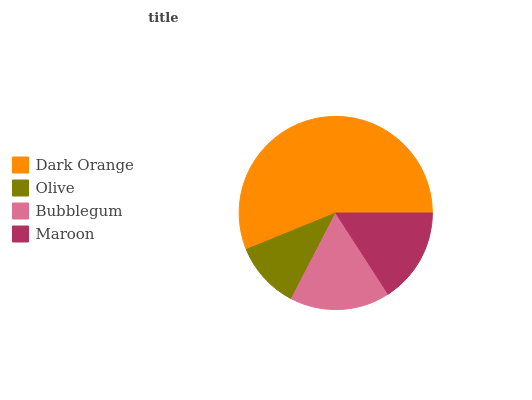Is Olive the minimum?
Answer yes or no. Yes. Is Dark Orange the maximum?
Answer yes or no. Yes. Is Bubblegum the minimum?
Answer yes or no. No. Is Bubblegum the maximum?
Answer yes or no. No. Is Bubblegum greater than Olive?
Answer yes or no. Yes. Is Olive less than Bubblegum?
Answer yes or no. Yes. Is Olive greater than Bubblegum?
Answer yes or no. No. Is Bubblegum less than Olive?
Answer yes or no. No. Is Bubblegum the high median?
Answer yes or no. Yes. Is Maroon the low median?
Answer yes or no. Yes. Is Olive the high median?
Answer yes or no. No. Is Olive the low median?
Answer yes or no. No. 